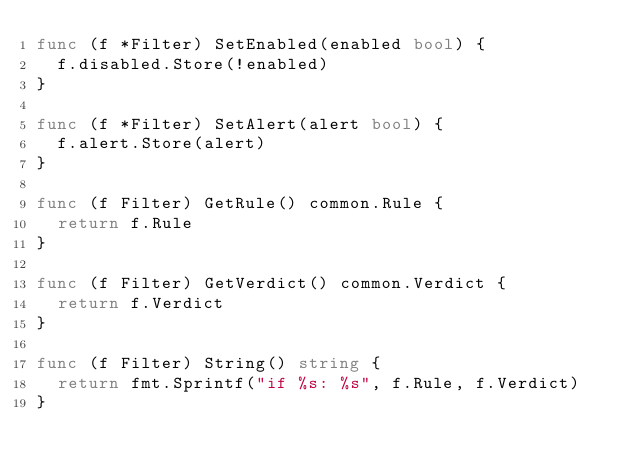<code> <loc_0><loc_0><loc_500><loc_500><_Go_>func (f *Filter) SetEnabled(enabled bool) {
	f.disabled.Store(!enabled)
}

func (f *Filter) SetAlert(alert bool) {
	f.alert.Store(alert)
}

func (f Filter) GetRule() common.Rule {
	return f.Rule
}

func (f Filter) GetVerdict() common.Verdict {
	return f.Verdict
}

func (f Filter) String() string {
	return fmt.Sprintf("if %s: %s", f.Rule, f.Verdict)
}
</code> 